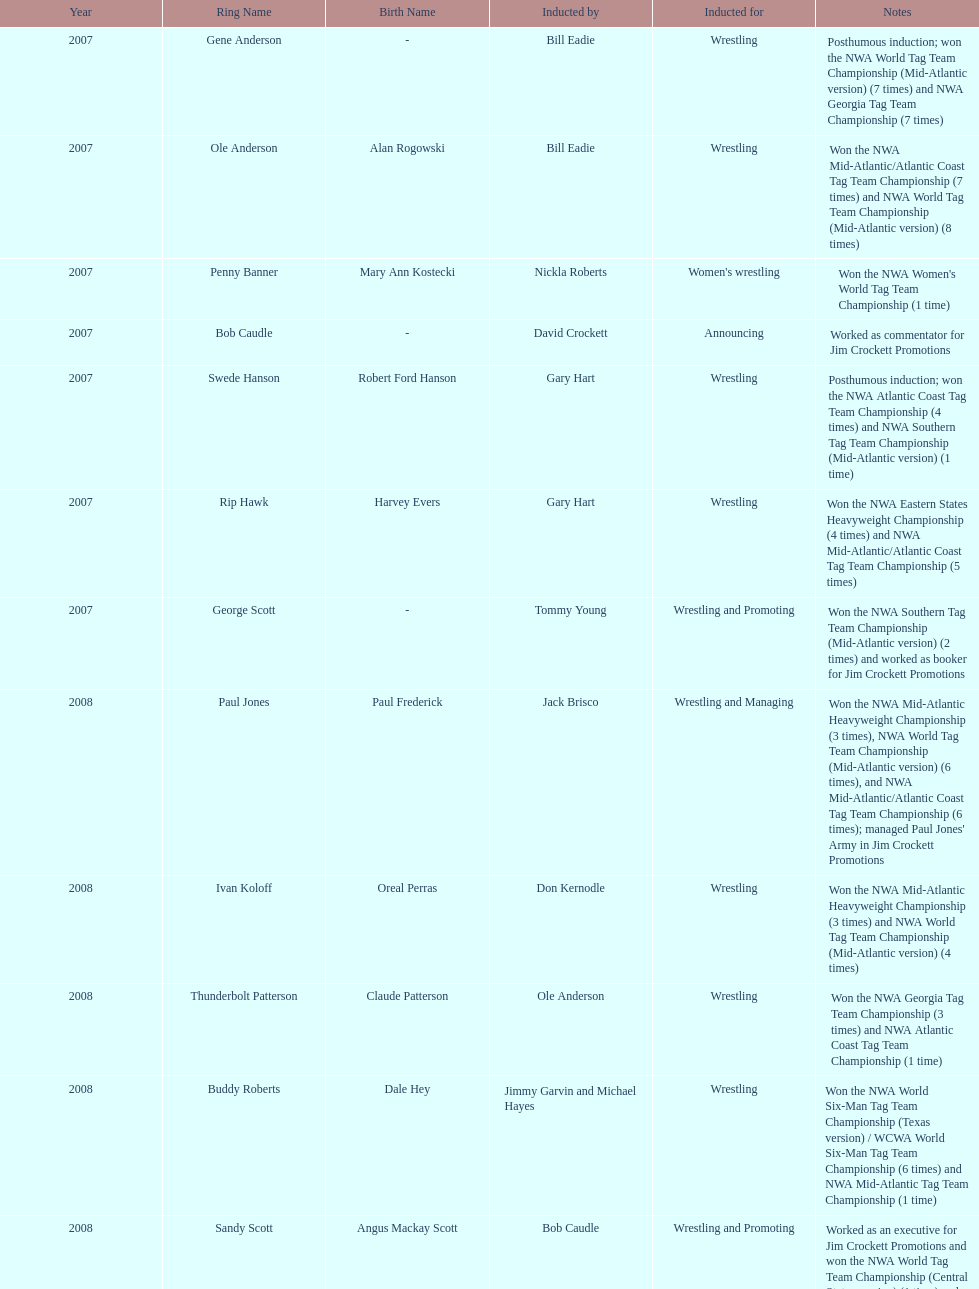Who was inducted after royal? Lance Russell. 